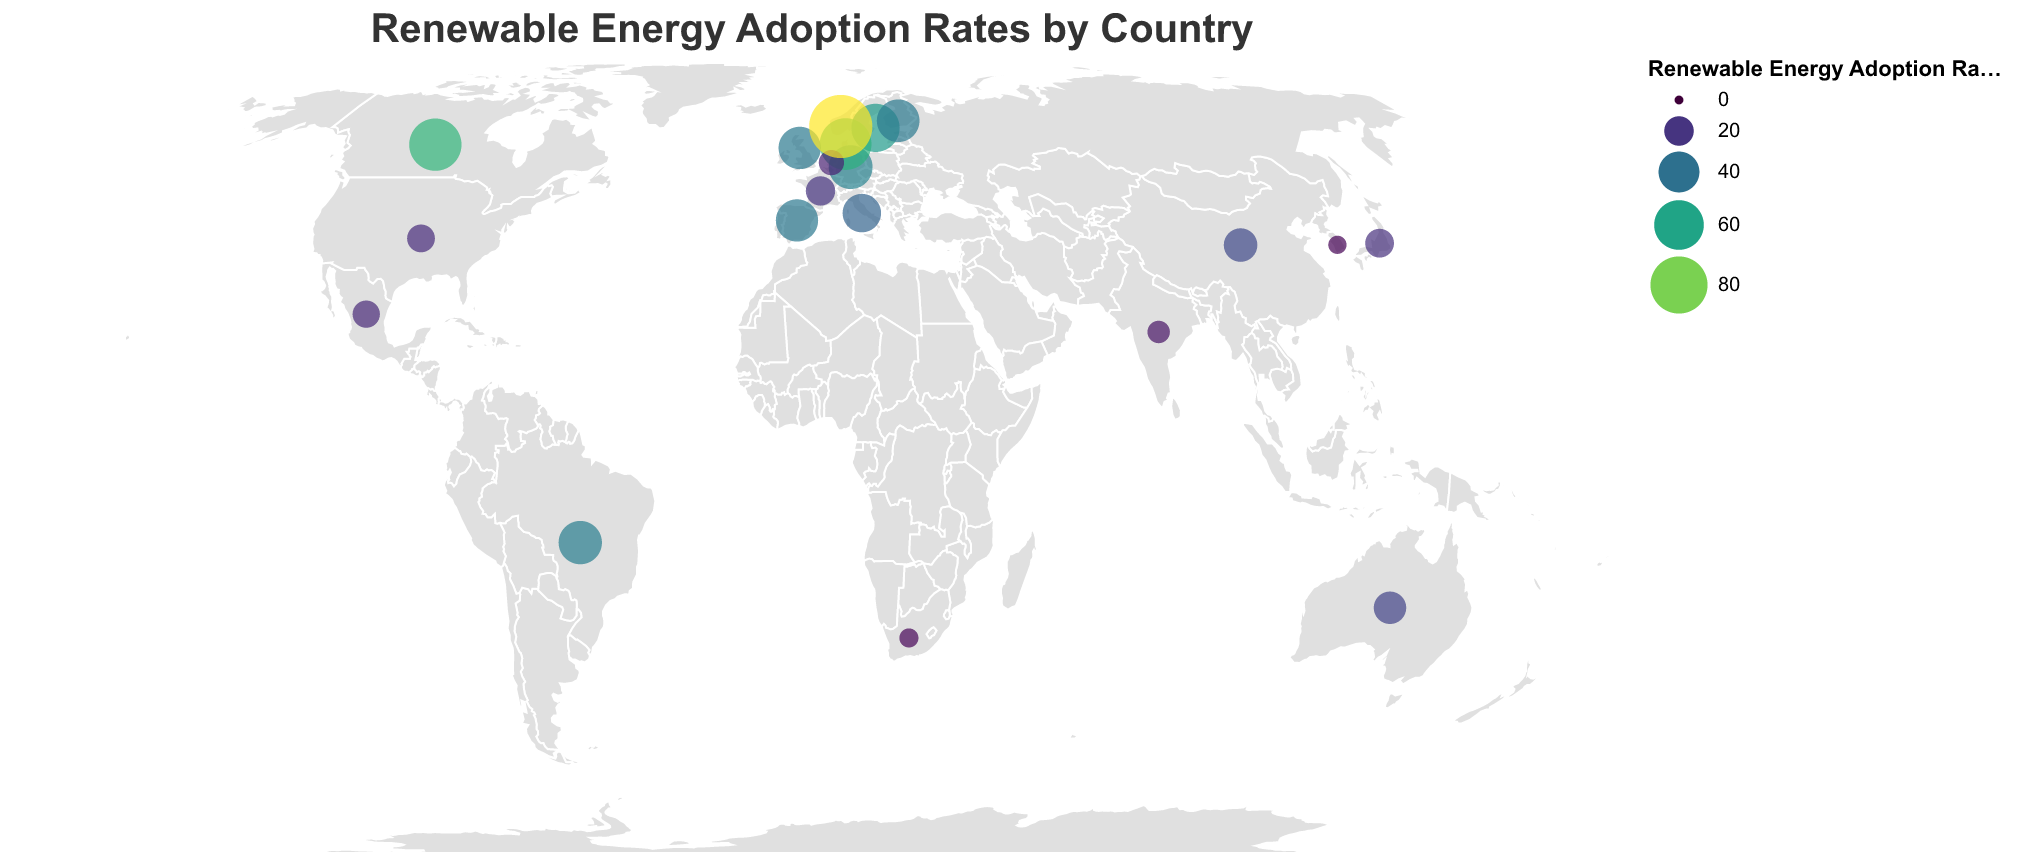What's the title of the figure? The title is the largest text typically located at the top of the figure and provides an overview of the content. Here, it reads "Renewable Energy Adoption Rates by Country".
Answer: Renewable Energy Adoption Rates by Country How many countries are represented in the figure? To find the number of countries, count the number of distinct data points in the plot. Each data point represents a country. In this case, the figure shows data for 20 countries.
Answer: 20 Which country has the highest renewable energy adoption rate? Look at the data points to find the one with the largest size and the highest color intensity in the color scale. Norway has the highest renewable energy adoption rate of 98.4%.
Answer: Norway Which country has the lowest renewable energy adoption rate? Find the smallest data point with the least intensity in its color. South Korea has the lowest renewable energy adoption rate of 6.4%.
Answer: South Korea What is the renewable energy adoption rate of Brazil? Locate the data point specifically representing Brazil and read the adoption rate value associated with it, which is 45.2%.
Answer: 45.2% Compare the renewable energy adoption rates of Canada and Denmark. Which one is higher? Find both Canada and Denmark in the plot and compare their adoption rates. Canada's rate is 66.8%, while Denmark's is 65.3%. Canada has the higher adoption rate.
Answer: Canada What is the average renewable energy adoption rate of Germany, the United Kingdom, and Australia? Add the adoption rates for Germany (46.3%), the United Kingdom (43.1%), and Australia (24.6%). Then divide the sum by 3. (46.3 + 43.1 + 24.6) / 3 = 38.0%
Answer: 38.0% Which continents are showing higher renewable energy adoption rates based on the countries presented? Observing the geographic distribution, European countries (Sweden, Denmark, Germany, United Kingdom, Spain, Norway, Finland) show higher adoption rates compared to countries in Asia, the Americas, and Africa.
Answer: Europe What is the difference in renewable energy adoption rates between the country with the highest and lowest rates? Subtract the lowest rate (South Korea, 6.4%) from the highest rate (Norway, 98.4%) to find the difference: 98.4% - 6.4% = 92%.
Answer: 92% Identify two countries from different continents with adoption rates above 40%. Examine the plot for countries from different continents with adoption rates above 40%. Notable examples are Canada (North America) and the United Kingdom (Europe).
Answer: Canada and United Kingdom 